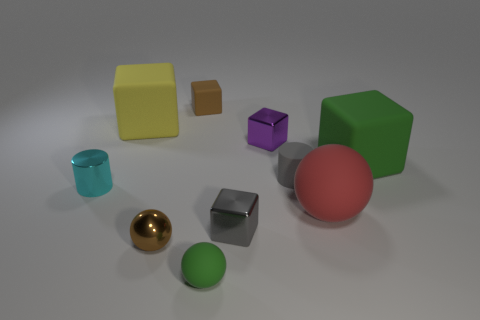What material is the tiny brown thing in front of the matte block in front of the big rubber cube behind the green cube made of?
Your answer should be very brief. Metal. What number of other objects are there of the same color as the small matte cube?
Your response must be concise. 1. How many purple objects are big rubber cylinders or tiny things?
Provide a short and direct response. 1. What is the material of the gray object that is to the right of the small purple shiny cube?
Keep it short and to the point. Rubber. Is the material of the green thing that is to the right of the purple block the same as the big red object?
Your response must be concise. Yes. What is the shape of the large yellow thing?
Your answer should be very brief. Cube. How many gray things are to the right of the small block in front of the green matte thing that is behind the tiny green rubber sphere?
Your response must be concise. 1. How many other things are the same material as the tiny gray block?
Provide a succinct answer. 3. What material is the cyan thing that is the same size as the brown metal ball?
Provide a short and direct response. Metal. There is a tiny cylinder that is on the right side of the brown cube; does it have the same color as the tiny metallic block that is in front of the tiny purple cube?
Make the answer very short. Yes. 